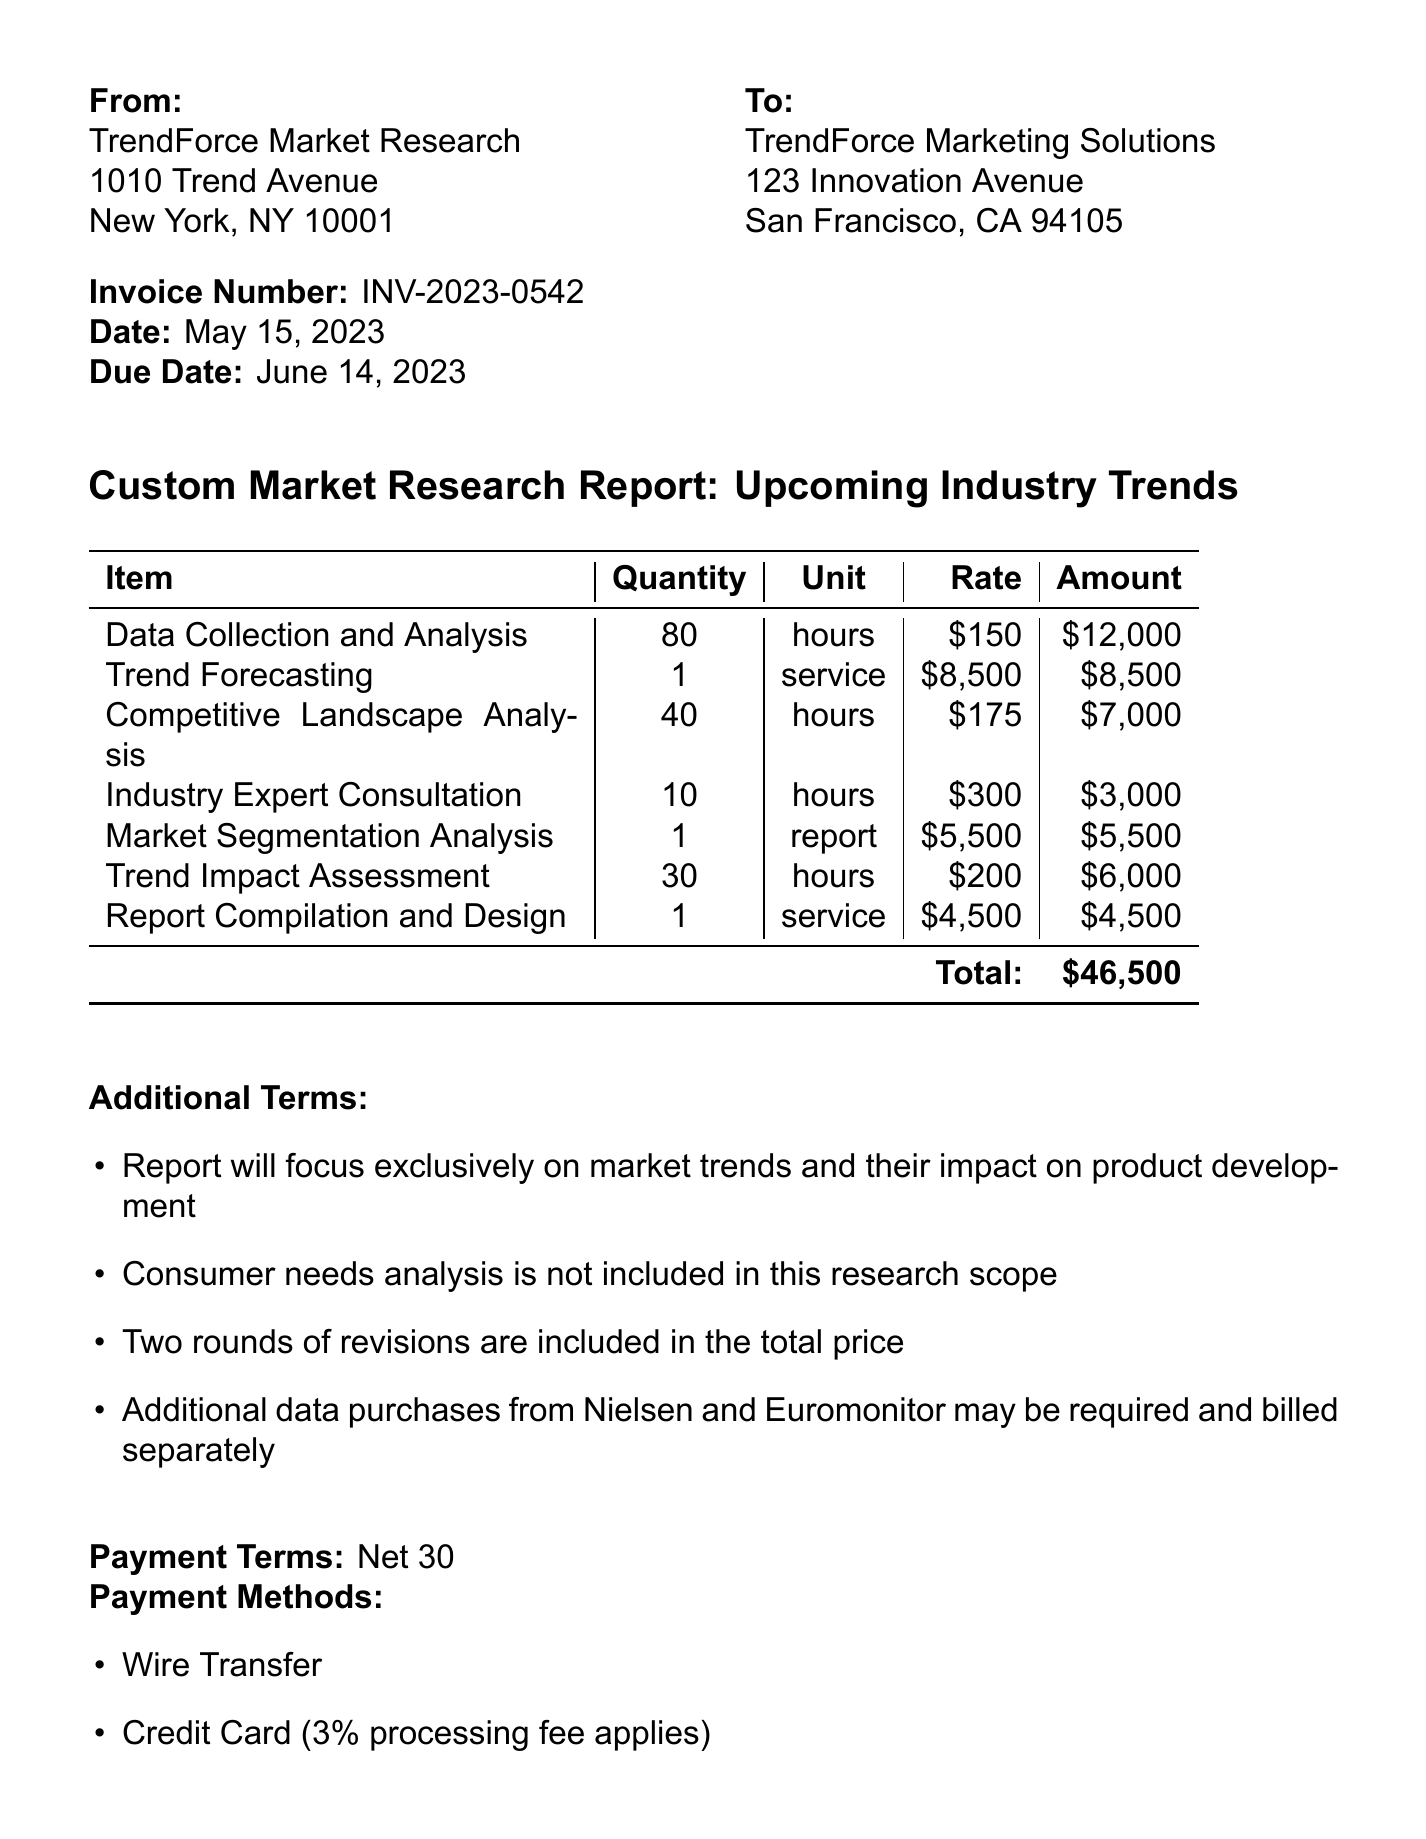what is the invoice number? The invoice number is a unique identifier for the invoice, listed at the top of the document.
Answer: INV-2023-0542 what is the date of the invoice? The date indicates when the invoice was issued, which is recorded in the document.
Answer: May 15, 2023 who is the client? The client's name is presented in the document under the recipient's details.
Answer: TrendForce Marketing Solutions what is the total amount due? The total amount due is the sum of all line items and is highlighted at the bottom of the invoice.
Answer: $46,500 how many hours were allocated for Data Collection and Analysis? The quantity of hours for each line item is specifically listed in the document.
Answer: 80 what is included in the additional terms? The additional terms provide specific details about what is and isn't included in the research scope, as well as limitations.
Answer: Report will focus exclusively on market trends and their impact on product development how many service items are listed in the document? The document contains several categories of items, and the question is about their total count.
Answer: 7 what payment method incurs a processing fee? The answer can be found in the payment methods section of the document.
Answer: Credit Card (3% processing fee applies) when is the payment due? The due date of the invoice can be found in the date section of the document.
Answer: June 14, 2023 